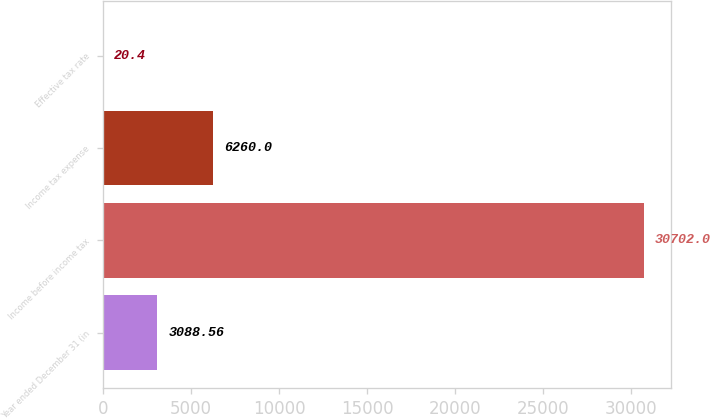Convert chart to OTSL. <chart><loc_0><loc_0><loc_500><loc_500><bar_chart><fcel>Year ended December 31 (in<fcel>Income before income tax<fcel>Income tax expense<fcel>Effective tax rate<nl><fcel>3088.56<fcel>30702<fcel>6260<fcel>20.4<nl></chart> 